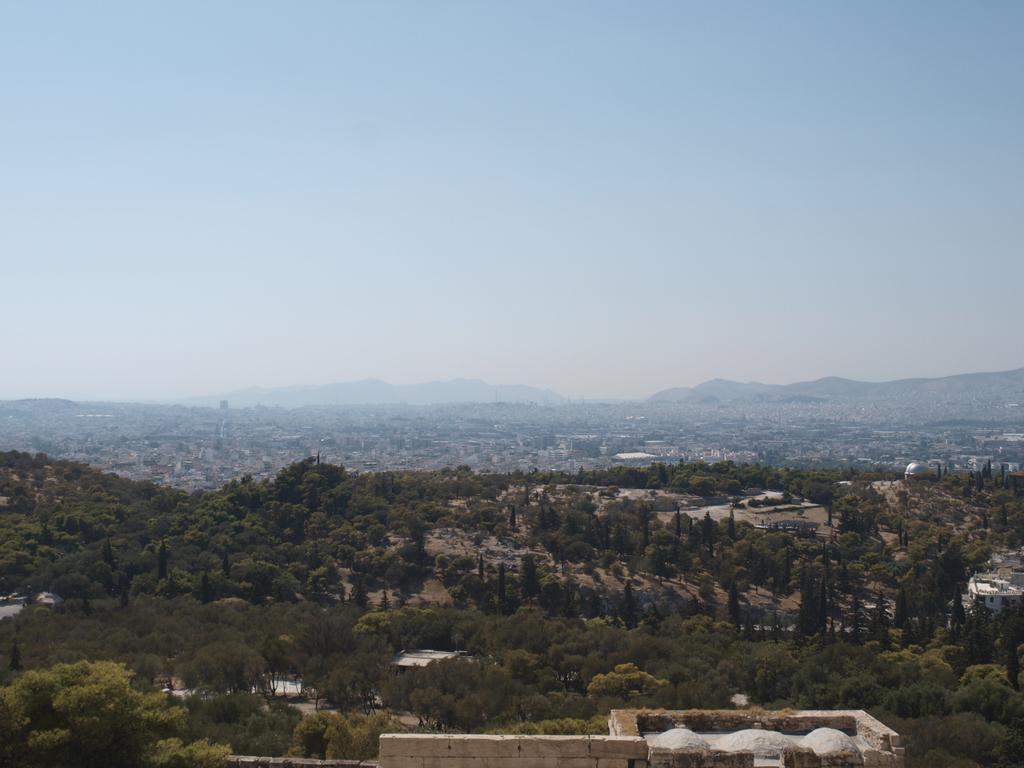Could you give a brief overview of what you see in this image? This picture is clicked outside the city. In the foreground we can see the buildings and the trees. In the background we can see the buildings and the sky. 